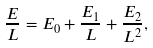Convert formula to latex. <formula><loc_0><loc_0><loc_500><loc_500>\frac { E } { L } = E _ { 0 } + \frac { E _ { 1 } } { L } + \frac { E _ { 2 } } { L ^ { 2 } } ,</formula> 